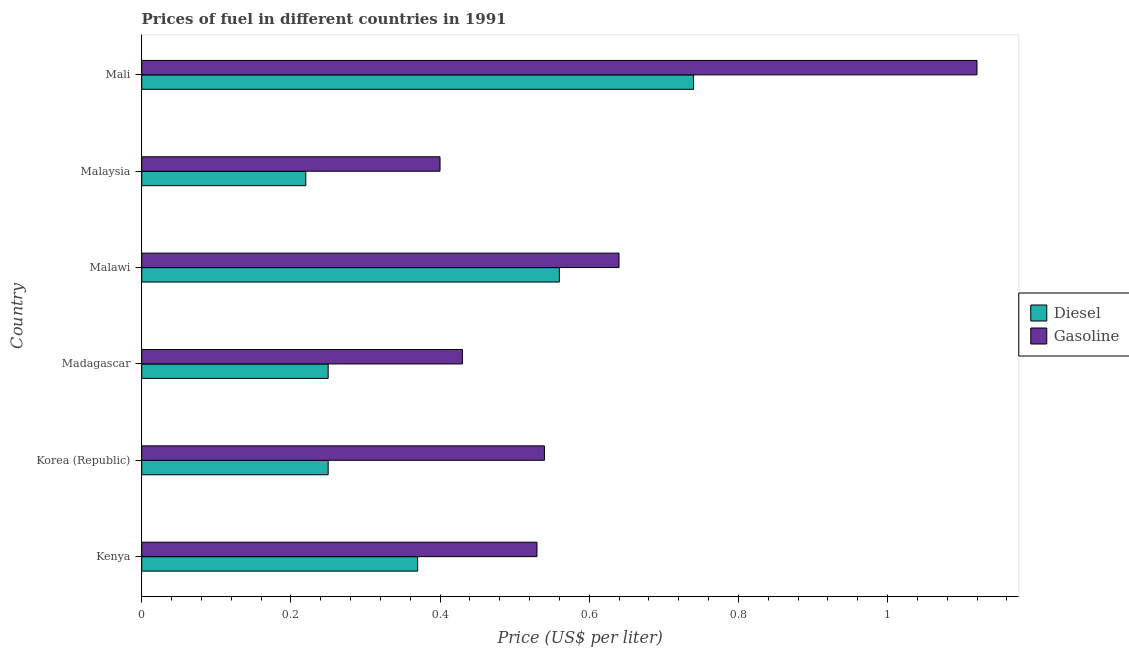How many groups of bars are there?
Make the answer very short. 6. What is the label of the 6th group of bars from the top?
Make the answer very short. Kenya. What is the diesel price in Korea (Republic)?
Offer a very short reply. 0.25. Across all countries, what is the maximum diesel price?
Offer a very short reply. 0.74. Across all countries, what is the minimum diesel price?
Keep it short and to the point. 0.22. In which country was the diesel price maximum?
Keep it short and to the point. Mali. In which country was the gasoline price minimum?
Ensure brevity in your answer.  Malaysia. What is the total gasoline price in the graph?
Give a very brief answer. 3.66. What is the difference between the gasoline price in Kenya and the diesel price in Madagascar?
Make the answer very short. 0.28. What is the average gasoline price per country?
Provide a short and direct response. 0.61. What is the difference between the diesel price and gasoline price in Kenya?
Keep it short and to the point. -0.16. What is the ratio of the gasoline price in Malaysia to that in Mali?
Keep it short and to the point. 0.36. Is the gasoline price in Kenya less than that in Malaysia?
Your answer should be very brief. No. What is the difference between the highest and the second highest gasoline price?
Keep it short and to the point. 0.48. What is the difference between the highest and the lowest diesel price?
Provide a succinct answer. 0.52. In how many countries, is the gasoline price greater than the average gasoline price taken over all countries?
Keep it short and to the point. 2. What does the 1st bar from the top in Malawi represents?
Your answer should be very brief. Gasoline. What does the 1st bar from the bottom in Korea (Republic) represents?
Ensure brevity in your answer.  Diesel. Are all the bars in the graph horizontal?
Keep it short and to the point. Yes. How many countries are there in the graph?
Offer a very short reply. 6. What is the difference between two consecutive major ticks on the X-axis?
Your response must be concise. 0.2. Are the values on the major ticks of X-axis written in scientific E-notation?
Provide a succinct answer. No. Does the graph contain grids?
Keep it short and to the point. No. Where does the legend appear in the graph?
Offer a terse response. Center right. What is the title of the graph?
Make the answer very short. Prices of fuel in different countries in 1991. Does "Non-pregnant women" appear as one of the legend labels in the graph?
Your answer should be very brief. No. What is the label or title of the X-axis?
Keep it short and to the point. Price (US$ per liter). What is the Price (US$ per liter) of Diesel in Kenya?
Provide a succinct answer. 0.37. What is the Price (US$ per liter) of Gasoline in Kenya?
Ensure brevity in your answer.  0.53. What is the Price (US$ per liter) in Diesel in Korea (Republic)?
Offer a terse response. 0.25. What is the Price (US$ per liter) in Gasoline in Korea (Republic)?
Your response must be concise. 0.54. What is the Price (US$ per liter) of Diesel in Madagascar?
Make the answer very short. 0.25. What is the Price (US$ per liter) in Gasoline in Madagascar?
Make the answer very short. 0.43. What is the Price (US$ per liter) of Diesel in Malawi?
Ensure brevity in your answer.  0.56. What is the Price (US$ per liter) in Gasoline in Malawi?
Provide a short and direct response. 0.64. What is the Price (US$ per liter) in Diesel in Malaysia?
Offer a very short reply. 0.22. What is the Price (US$ per liter) in Gasoline in Malaysia?
Ensure brevity in your answer.  0.4. What is the Price (US$ per liter) of Diesel in Mali?
Your answer should be very brief. 0.74. What is the Price (US$ per liter) of Gasoline in Mali?
Offer a terse response. 1.12. Across all countries, what is the maximum Price (US$ per liter) of Diesel?
Offer a very short reply. 0.74. Across all countries, what is the maximum Price (US$ per liter) of Gasoline?
Ensure brevity in your answer.  1.12. Across all countries, what is the minimum Price (US$ per liter) of Diesel?
Provide a succinct answer. 0.22. What is the total Price (US$ per liter) of Diesel in the graph?
Make the answer very short. 2.39. What is the total Price (US$ per liter) in Gasoline in the graph?
Your answer should be very brief. 3.66. What is the difference between the Price (US$ per liter) of Diesel in Kenya and that in Korea (Republic)?
Your answer should be compact. 0.12. What is the difference between the Price (US$ per liter) in Gasoline in Kenya and that in Korea (Republic)?
Your answer should be compact. -0.01. What is the difference between the Price (US$ per liter) of Diesel in Kenya and that in Madagascar?
Your answer should be compact. 0.12. What is the difference between the Price (US$ per liter) of Diesel in Kenya and that in Malawi?
Your answer should be very brief. -0.19. What is the difference between the Price (US$ per liter) in Gasoline in Kenya and that in Malawi?
Offer a terse response. -0.11. What is the difference between the Price (US$ per liter) of Gasoline in Kenya and that in Malaysia?
Give a very brief answer. 0.13. What is the difference between the Price (US$ per liter) of Diesel in Kenya and that in Mali?
Make the answer very short. -0.37. What is the difference between the Price (US$ per liter) in Gasoline in Kenya and that in Mali?
Provide a succinct answer. -0.59. What is the difference between the Price (US$ per liter) in Gasoline in Korea (Republic) and that in Madagascar?
Give a very brief answer. 0.11. What is the difference between the Price (US$ per liter) in Diesel in Korea (Republic) and that in Malawi?
Your answer should be very brief. -0.31. What is the difference between the Price (US$ per liter) in Diesel in Korea (Republic) and that in Malaysia?
Offer a terse response. 0.03. What is the difference between the Price (US$ per liter) of Gasoline in Korea (Republic) and that in Malaysia?
Ensure brevity in your answer.  0.14. What is the difference between the Price (US$ per liter) in Diesel in Korea (Republic) and that in Mali?
Your response must be concise. -0.49. What is the difference between the Price (US$ per liter) in Gasoline in Korea (Republic) and that in Mali?
Your answer should be compact. -0.58. What is the difference between the Price (US$ per liter) in Diesel in Madagascar and that in Malawi?
Ensure brevity in your answer.  -0.31. What is the difference between the Price (US$ per liter) of Gasoline in Madagascar and that in Malawi?
Your answer should be compact. -0.21. What is the difference between the Price (US$ per liter) in Diesel in Madagascar and that in Malaysia?
Your response must be concise. 0.03. What is the difference between the Price (US$ per liter) of Gasoline in Madagascar and that in Malaysia?
Provide a succinct answer. 0.03. What is the difference between the Price (US$ per liter) of Diesel in Madagascar and that in Mali?
Provide a short and direct response. -0.49. What is the difference between the Price (US$ per liter) in Gasoline in Madagascar and that in Mali?
Give a very brief answer. -0.69. What is the difference between the Price (US$ per liter) in Diesel in Malawi and that in Malaysia?
Keep it short and to the point. 0.34. What is the difference between the Price (US$ per liter) of Gasoline in Malawi and that in Malaysia?
Your answer should be very brief. 0.24. What is the difference between the Price (US$ per liter) of Diesel in Malawi and that in Mali?
Offer a very short reply. -0.18. What is the difference between the Price (US$ per liter) of Gasoline in Malawi and that in Mali?
Make the answer very short. -0.48. What is the difference between the Price (US$ per liter) in Diesel in Malaysia and that in Mali?
Your answer should be very brief. -0.52. What is the difference between the Price (US$ per liter) of Gasoline in Malaysia and that in Mali?
Provide a short and direct response. -0.72. What is the difference between the Price (US$ per liter) in Diesel in Kenya and the Price (US$ per liter) in Gasoline in Korea (Republic)?
Ensure brevity in your answer.  -0.17. What is the difference between the Price (US$ per liter) in Diesel in Kenya and the Price (US$ per liter) in Gasoline in Madagascar?
Your answer should be compact. -0.06. What is the difference between the Price (US$ per liter) in Diesel in Kenya and the Price (US$ per liter) in Gasoline in Malawi?
Your answer should be compact. -0.27. What is the difference between the Price (US$ per liter) of Diesel in Kenya and the Price (US$ per liter) of Gasoline in Malaysia?
Provide a short and direct response. -0.03. What is the difference between the Price (US$ per liter) of Diesel in Kenya and the Price (US$ per liter) of Gasoline in Mali?
Offer a very short reply. -0.75. What is the difference between the Price (US$ per liter) in Diesel in Korea (Republic) and the Price (US$ per liter) in Gasoline in Madagascar?
Offer a terse response. -0.18. What is the difference between the Price (US$ per liter) of Diesel in Korea (Republic) and the Price (US$ per liter) of Gasoline in Malawi?
Offer a terse response. -0.39. What is the difference between the Price (US$ per liter) of Diesel in Korea (Republic) and the Price (US$ per liter) of Gasoline in Malaysia?
Provide a succinct answer. -0.15. What is the difference between the Price (US$ per liter) in Diesel in Korea (Republic) and the Price (US$ per liter) in Gasoline in Mali?
Make the answer very short. -0.87. What is the difference between the Price (US$ per liter) in Diesel in Madagascar and the Price (US$ per liter) in Gasoline in Malawi?
Provide a succinct answer. -0.39. What is the difference between the Price (US$ per liter) in Diesel in Madagascar and the Price (US$ per liter) in Gasoline in Malaysia?
Offer a very short reply. -0.15. What is the difference between the Price (US$ per liter) in Diesel in Madagascar and the Price (US$ per liter) in Gasoline in Mali?
Offer a terse response. -0.87. What is the difference between the Price (US$ per liter) of Diesel in Malawi and the Price (US$ per liter) of Gasoline in Malaysia?
Ensure brevity in your answer.  0.16. What is the difference between the Price (US$ per liter) in Diesel in Malawi and the Price (US$ per liter) in Gasoline in Mali?
Provide a succinct answer. -0.56. What is the average Price (US$ per liter) of Diesel per country?
Your answer should be very brief. 0.4. What is the average Price (US$ per liter) in Gasoline per country?
Offer a terse response. 0.61. What is the difference between the Price (US$ per liter) of Diesel and Price (US$ per liter) of Gasoline in Kenya?
Provide a succinct answer. -0.16. What is the difference between the Price (US$ per liter) of Diesel and Price (US$ per liter) of Gasoline in Korea (Republic)?
Provide a succinct answer. -0.29. What is the difference between the Price (US$ per liter) of Diesel and Price (US$ per liter) of Gasoline in Madagascar?
Keep it short and to the point. -0.18. What is the difference between the Price (US$ per liter) in Diesel and Price (US$ per liter) in Gasoline in Malawi?
Your answer should be compact. -0.08. What is the difference between the Price (US$ per liter) in Diesel and Price (US$ per liter) in Gasoline in Malaysia?
Provide a short and direct response. -0.18. What is the difference between the Price (US$ per liter) in Diesel and Price (US$ per liter) in Gasoline in Mali?
Ensure brevity in your answer.  -0.38. What is the ratio of the Price (US$ per liter) in Diesel in Kenya to that in Korea (Republic)?
Offer a very short reply. 1.48. What is the ratio of the Price (US$ per liter) of Gasoline in Kenya to that in Korea (Republic)?
Give a very brief answer. 0.98. What is the ratio of the Price (US$ per liter) in Diesel in Kenya to that in Madagascar?
Your answer should be compact. 1.48. What is the ratio of the Price (US$ per liter) of Gasoline in Kenya to that in Madagascar?
Your response must be concise. 1.23. What is the ratio of the Price (US$ per liter) of Diesel in Kenya to that in Malawi?
Provide a succinct answer. 0.66. What is the ratio of the Price (US$ per liter) in Gasoline in Kenya to that in Malawi?
Ensure brevity in your answer.  0.83. What is the ratio of the Price (US$ per liter) in Diesel in Kenya to that in Malaysia?
Offer a terse response. 1.68. What is the ratio of the Price (US$ per liter) in Gasoline in Kenya to that in Malaysia?
Offer a terse response. 1.32. What is the ratio of the Price (US$ per liter) in Gasoline in Kenya to that in Mali?
Provide a succinct answer. 0.47. What is the ratio of the Price (US$ per liter) of Gasoline in Korea (Republic) to that in Madagascar?
Your answer should be very brief. 1.26. What is the ratio of the Price (US$ per liter) of Diesel in Korea (Republic) to that in Malawi?
Offer a very short reply. 0.45. What is the ratio of the Price (US$ per liter) in Gasoline in Korea (Republic) to that in Malawi?
Give a very brief answer. 0.84. What is the ratio of the Price (US$ per liter) in Diesel in Korea (Republic) to that in Malaysia?
Make the answer very short. 1.14. What is the ratio of the Price (US$ per liter) of Gasoline in Korea (Republic) to that in Malaysia?
Ensure brevity in your answer.  1.35. What is the ratio of the Price (US$ per liter) in Diesel in Korea (Republic) to that in Mali?
Keep it short and to the point. 0.34. What is the ratio of the Price (US$ per liter) in Gasoline in Korea (Republic) to that in Mali?
Give a very brief answer. 0.48. What is the ratio of the Price (US$ per liter) of Diesel in Madagascar to that in Malawi?
Your answer should be very brief. 0.45. What is the ratio of the Price (US$ per liter) of Gasoline in Madagascar to that in Malawi?
Your response must be concise. 0.67. What is the ratio of the Price (US$ per liter) of Diesel in Madagascar to that in Malaysia?
Your answer should be very brief. 1.14. What is the ratio of the Price (US$ per liter) in Gasoline in Madagascar to that in Malaysia?
Keep it short and to the point. 1.07. What is the ratio of the Price (US$ per liter) of Diesel in Madagascar to that in Mali?
Your answer should be compact. 0.34. What is the ratio of the Price (US$ per liter) in Gasoline in Madagascar to that in Mali?
Offer a very short reply. 0.38. What is the ratio of the Price (US$ per liter) in Diesel in Malawi to that in Malaysia?
Provide a short and direct response. 2.55. What is the ratio of the Price (US$ per liter) of Gasoline in Malawi to that in Malaysia?
Offer a very short reply. 1.6. What is the ratio of the Price (US$ per liter) of Diesel in Malawi to that in Mali?
Provide a succinct answer. 0.76. What is the ratio of the Price (US$ per liter) of Diesel in Malaysia to that in Mali?
Make the answer very short. 0.3. What is the ratio of the Price (US$ per liter) of Gasoline in Malaysia to that in Mali?
Provide a succinct answer. 0.36. What is the difference between the highest and the second highest Price (US$ per liter) of Diesel?
Provide a succinct answer. 0.18. What is the difference between the highest and the second highest Price (US$ per liter) of Gasoline?
Your answer should be very brief. 0.48. What is the difference between the highest and the lowest Price (US$ per liter) in Diesel?
Provide a short and direct response. 0.52. What is the difference between the highest and the lowest Price (US$ per liter) of Gasoline?
Give a very brief answer. 0.72. 